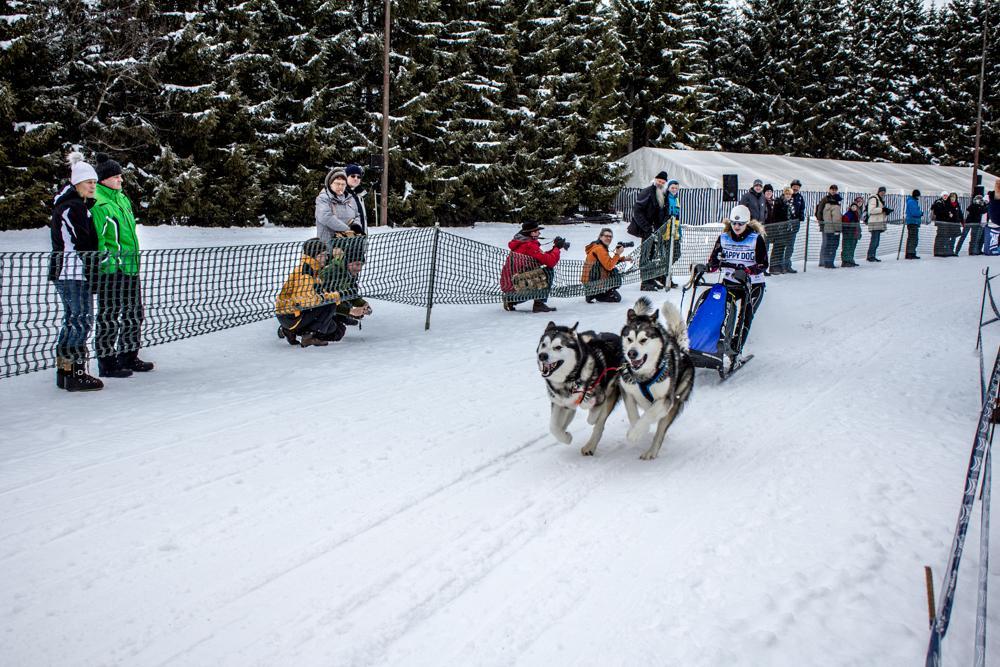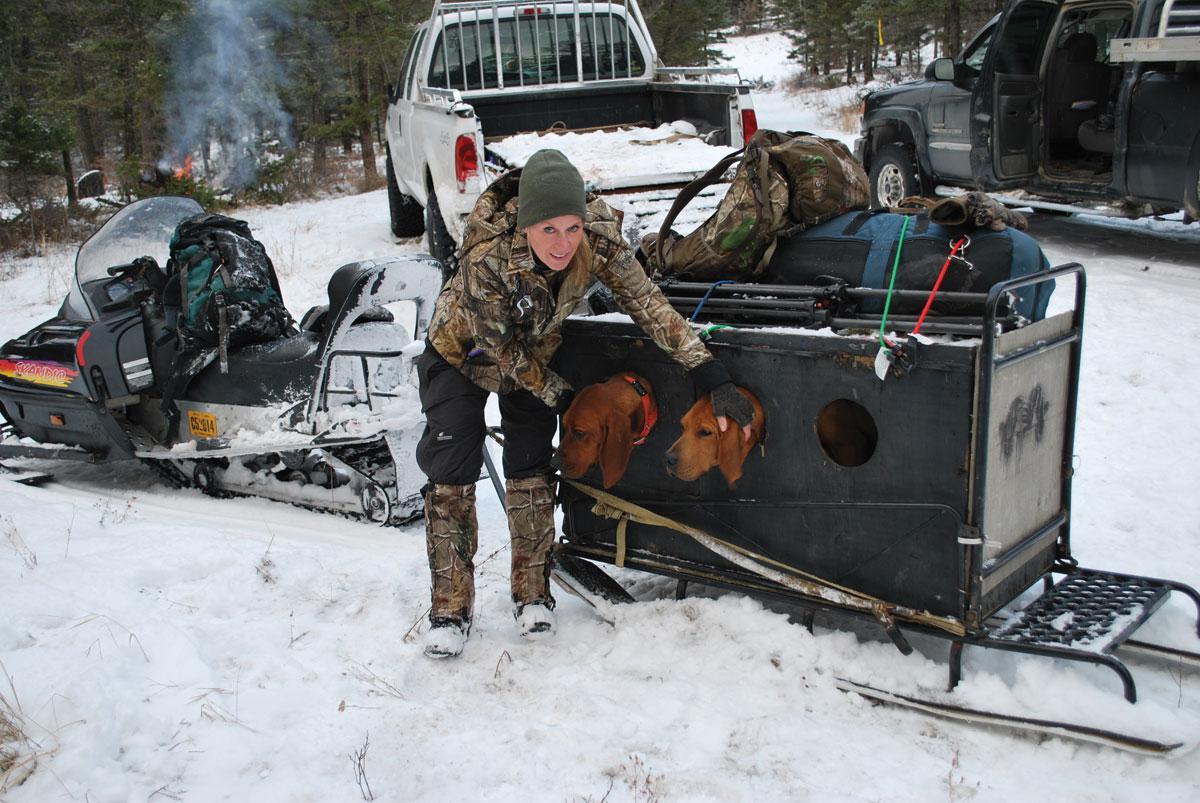The first image is the image on the left, the second image is the image on the right. Examine the images to the left and right. Is the description "One image shows an empty, unhitched, leftward-facing sled in the foreground, and the other image includes sled dogs in the foreground." accurate? Answer yes or no. No. The first image is the image on the left, the second image is the image on the right. For the images shown, is this caption "One image shows dogs that are part of a sled racing team and the other shows only the sled." true? Answer yes or no. No. 